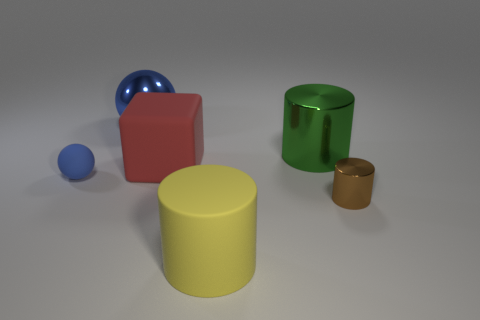What number of yellow cylinders are in front of the green metal cylinder?
Offer a very short reply. 1. What is the color of the tiny object that is the same material as the big green cylinder?
Keep it short and to the point. Brown. There is a brown shiny cylinder; does it have the same size as the blue object that is behind the tiny sphere?
Ensure brevity in your answer.  No. What size is the metallic cylinder that is in front of the rubber thing that is to the left of the blue sphere that is behind the tiny blue ball?
Give a very brief answer. Small. What number of metal things are small blue objects or yellow things?
Give a very brief answer. 0. What is the color of the cylinder that is behind the brown metal cylinder?
Your answer should be compact. Green. What is the shape of the green metal thing that is the same size as the yellow thing?
Your answer should be very brief. Cylinder. There is a matte sphere; is its color the same as the ball that is right of the tiny blue matte ball?
Your response must be concise. Yes. What number of objects are big rubber objects behind the small brown shiny thing or large matte things that are behind the yellow rubber cylinder?
Your answer should be compact. 1. There is a blue ball that is the same size as the green cylinder; what is it made of?
Your answer should be very brief. Metal. 